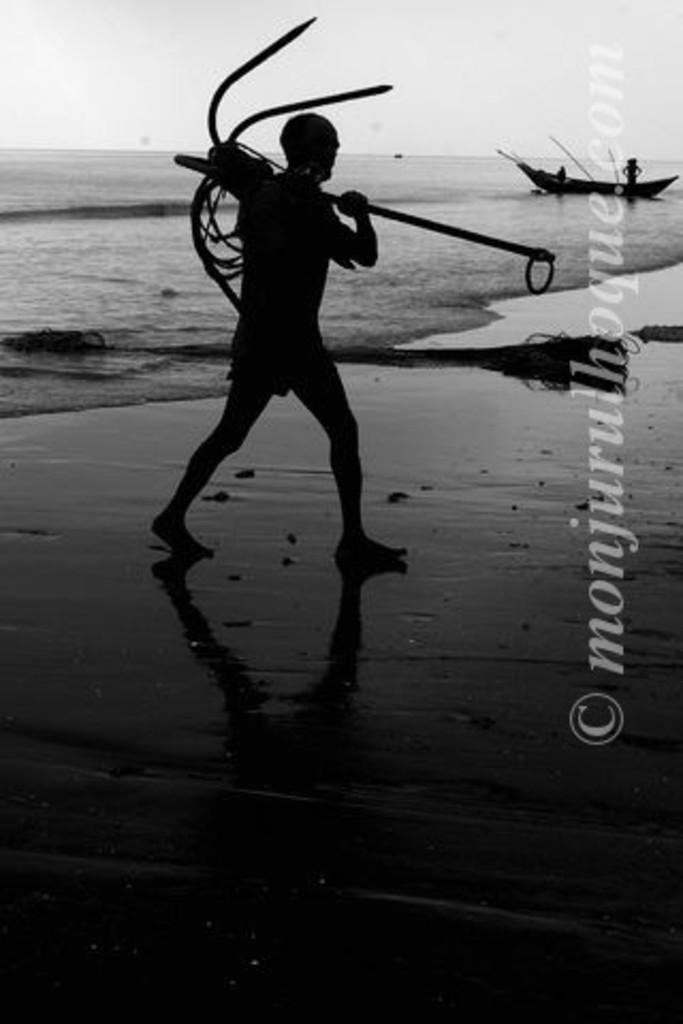<image>
Create a compact narrative representing the image presented. a man carries a big anchor by a watermark reading Monjurulhoque 